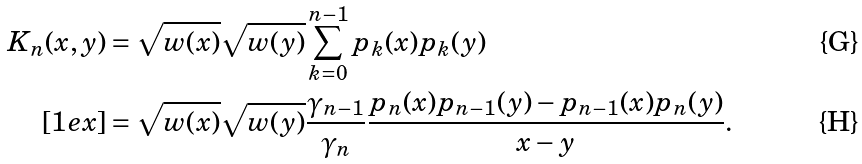<formula> <loc_0><loc_0><loc_500><loc_500>K _ { n } ( x , y ) & = \sqrt { w ( x ) } \sqrt { w ( y ) } \sum _ { k = 0 } ^ { n - 1 } p _ { k } ( x ) p _ { k } ( y ) \\ [ 1 e x ] & = \sqrt { w ( x ) } \sqrt { w ( y ) } \frac { \gamma _ { n - 1 } } { \gamma _ { n } } \frac { p _ { n } ( x ) p _ { n - 1 } ( y ) - p _ { n - 1 } ( x ) p _ { n } ( y ) } { x - y } .</formula> 